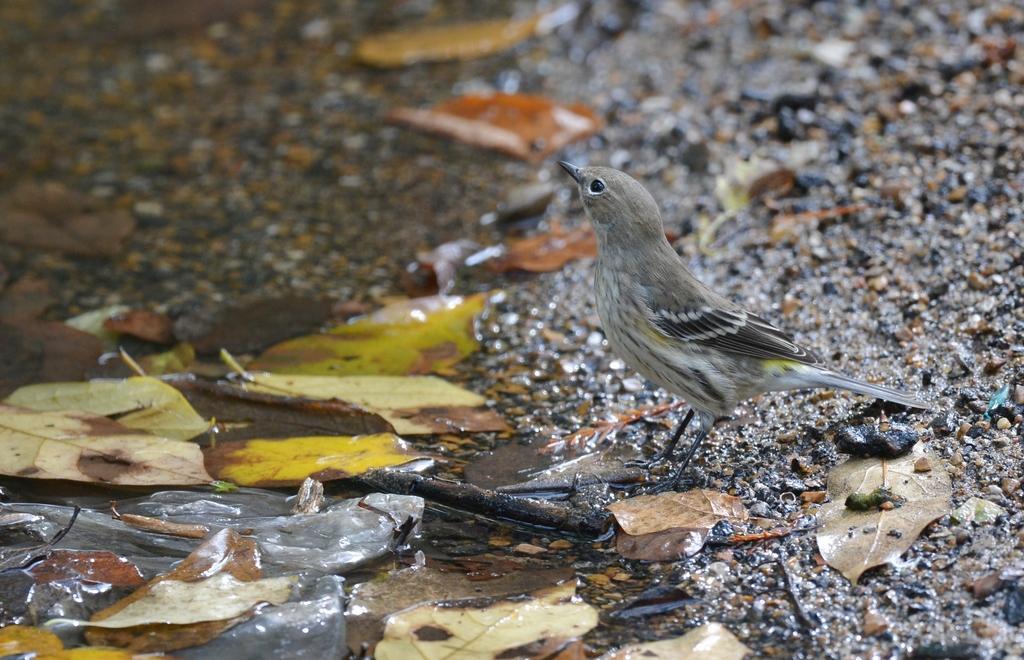Could you give a brief overview of what you see in this image? In the given image i can see a bird,leaves and water. 